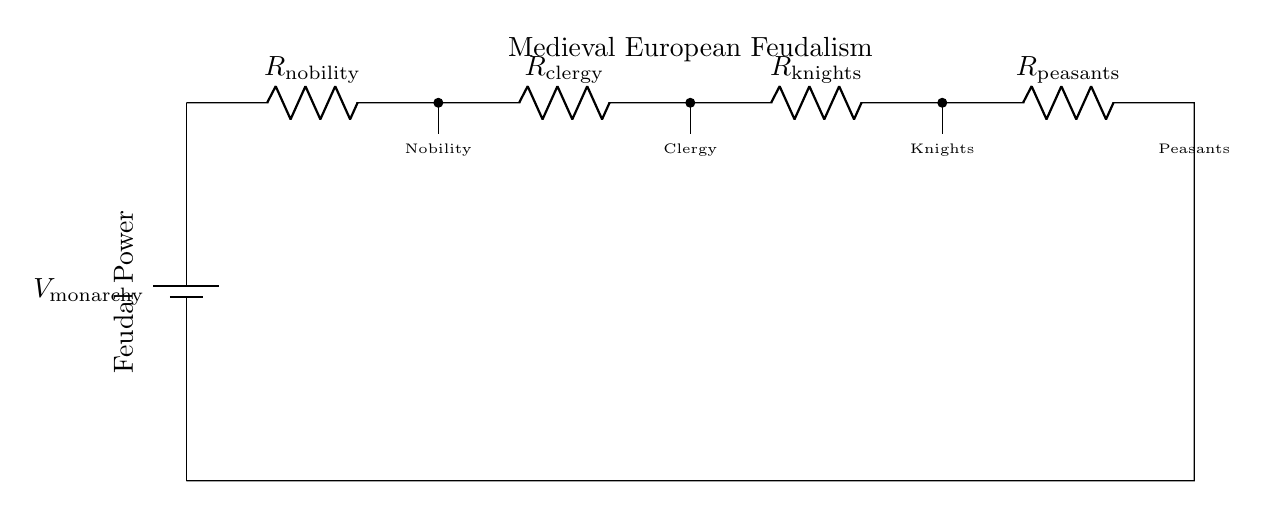What is the total resistance in this voltage divider? The circuit consists of four resistors in series: nobility, clergy, knights, and peasants. To find the total resistance, we simply add them together: R_total = R_nobility + R_clergy + R_knights + R_peasants.
Answer: R_nobility + R_clergy + R_knights + R_peasants What does the voltage at the nobility node represent? The voltage at this node is a division of the total voltage generated by the monarchy battery. Since it is the first resistor in the series, the voltage drop across it represents the nobility's share of the feudal power.
Answer: Nobility's share of feudal power Who is at the bottom of the feudal hierarchy represented in the circuit? In the hierarchy illustrated by this circuit, the last resistor, which has no branching, represents the peasants. Their position at the bottom signifies that they receive the least power or voltage in this structure.
Answer: Peasants What can we infer about the current in this circuit? In a series circuit, the current is the same through all components. Therefore, the current flowing through nobility, clergy, knights, and peasants is equal. It shows that power is distributed evenly in terms of current but not in voltage.
Answer: Same current through all What does the battery voltage symbolize in this circuit? The battery voltage, labeled as V_monarchy, symbolizes the total power or authority held by the monarchy. This is the source from which all other hierarchical power (voltage drops) is derived.
Answer: Total power of the monarchy 